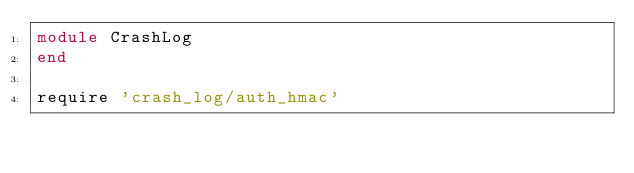Convert code to text. <code><loc_0><loc_0><loc_500><loc_500><_Ruby_>module CrashLog
end

require 'crash_log/auth_hmac'
</code> 